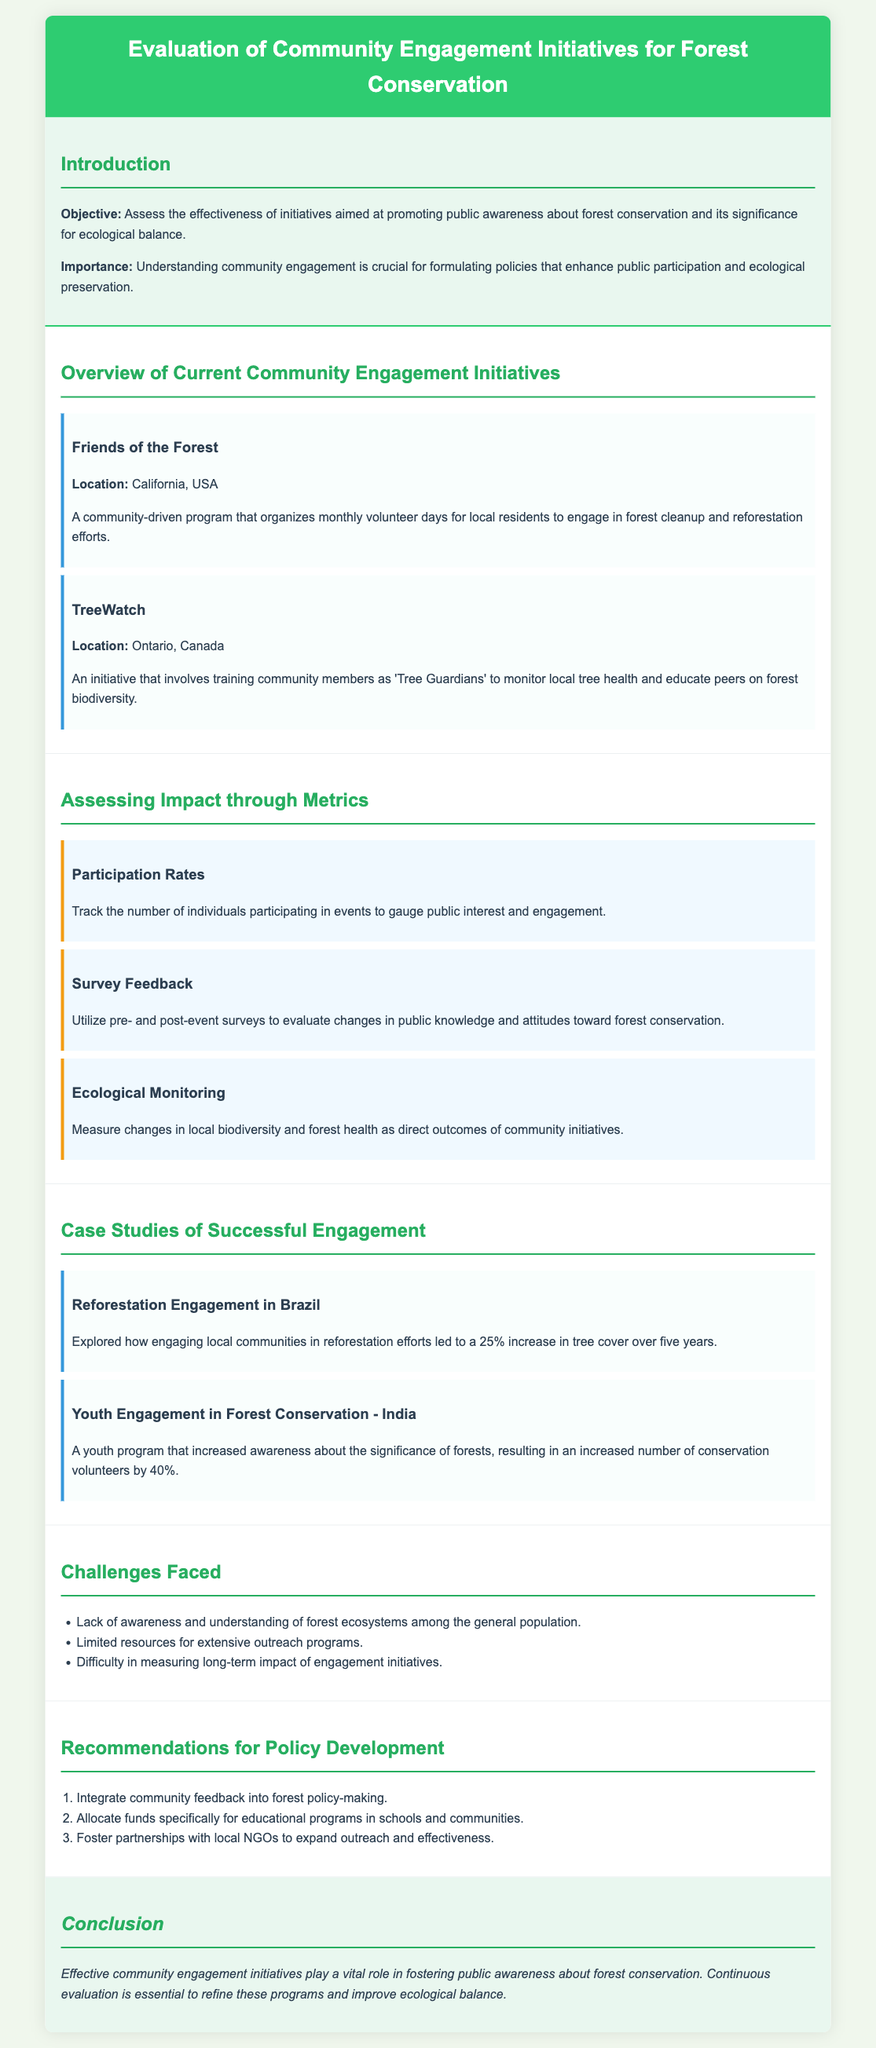what is the objective of the evaluation? The objective is to assess the effectiveness of initiatives aimed at promoting public awareness about forest conservation and its significance for ecological balance.
Answer: assess the effectiveness where is the "Friends of the Forest" initiative located? The location of the "Friends of the Forest" initiative is provided in the document.
Answer: California, USA what is one of the metrics used to assess impact? The document lists various metrics, one of which is specified.
Answer: Participation Rates how much did tree cover increase in Brazil due to engagement? The document states a percentage increase in tree cover as a result of reforestation efforts.
Answer: 25% what are the challenges faced in community engagement initiatives? Challenges are listed, and one example is included in the document.
Answer: Lack of awareness what is a recommendation for policy development mentioned? The document suggests several recommendations; one is noted here.
Answer: Integrate community feedback how much did conservation volunteers increase in the youth program in India? The document provides a percentage increase regarding conservation volunteers.
Answer: 40% which initiative involves training community members as 'Tree Guardians'? The document specifically names an initiative associated with this training.
Answer: TreeWatch what is the importance of understanding community engagement? The document explains the reasoning behind the importance of understanding community engagement for policy formulation.
Answer: Enhance public participation 